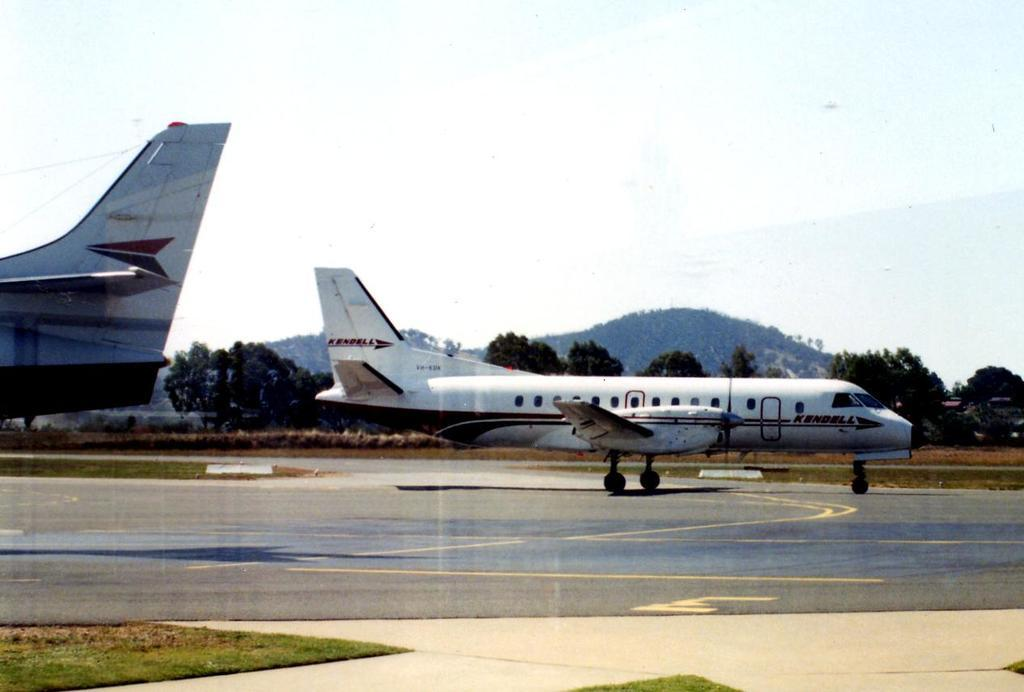Provide a one-sentence caption for the provided image. On the tarmat with large jets and the medium size Kendell jet taking off. 